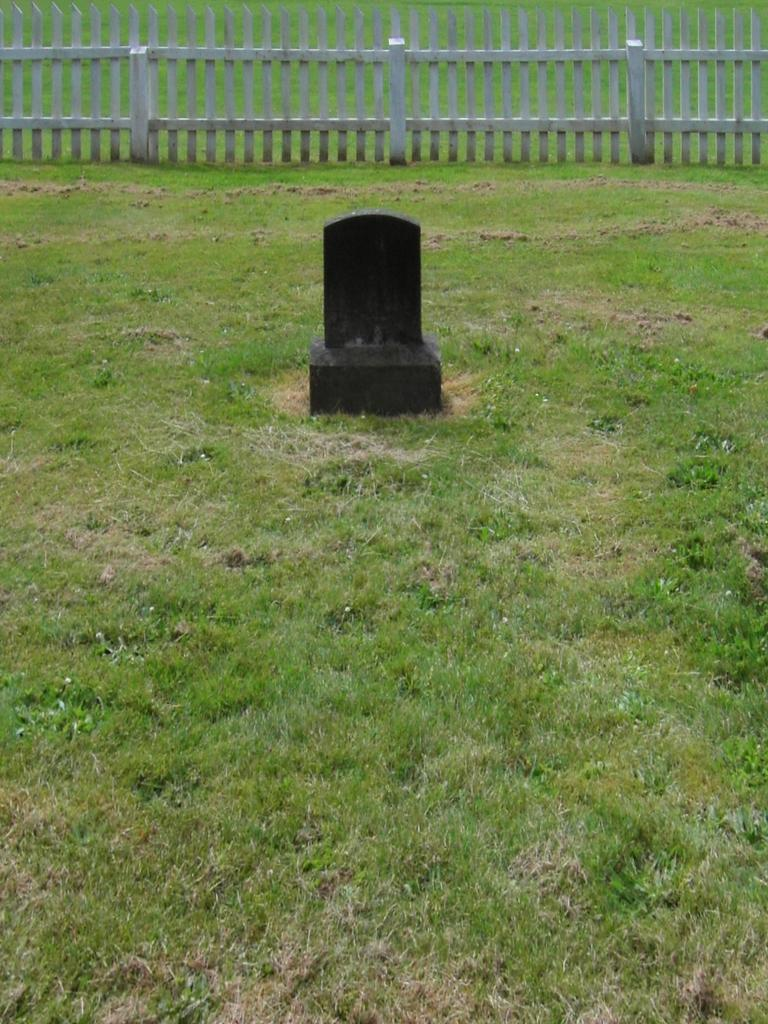What is the main subject in the foreground of the image? There is a headstone in the foreground of the image. What type of surface is the headstone placed on? The headstone is on grass. What can be seen at the top of the image? There is wooden fencing at the top of the image. What type of rock is the achiever holding in the image? There is no achiever or rock present in the image; it features a headstone on grass with wooden fencing at the top. 